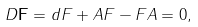Convert formula to latex. <formula><loc_0><loc_0><loc_500><loc_500>D \mathbf { F } = d F + A F - F A = 0 ,</formula> 